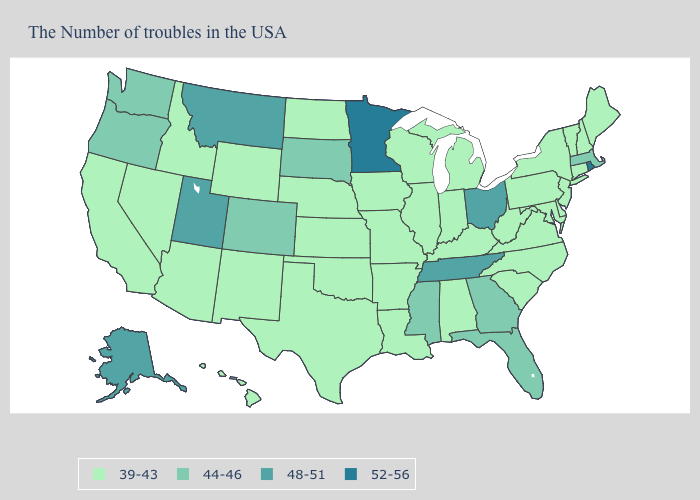Does Idaho have the same value as Oklahoma?
Write a very short answer. Yes. What is the highest value in the South ?
Be succinct. 48-51. What is the value of Kansas?
Give a very brief answer. 39-43. Name the states that have a value in the range 44-46?
Quick response, please. Massachusetts, Florida, Georgia, Mississippi, South Dakota, Colorado, Washington, Oregon. What is the lowest value in states that border Louisiana?
Answer briefly. 39-43. Which states have the lowest value in the USA?
Be succinct. Maine, New Hampshire, Vermont, Connecticut, New York, New Jersey, Delaware, Maryland, Pennsylvania, Virginia, North Carolina, South Carolina, West Virginia, Michigan, Kentucky, Indiana, Alabama, Wisconsin, Illinois, Louisiana, Missouri, Arkansas, Iowa, Kansas, Nebraska, Oklahoma, Texas, North Dakota, Wyoming, New Mexico, Arizona, Idaho, Nevada, California, Hawaii. What is the lowest value in states that border Nevada?
Answer briefly. 39-43. What is the value of Florida?
Concise answer only. 44-46. Does the first symbol in the legend represent the smallest category?
Give a very brief answer. Yes. Does Nebraska have the same value as New York?
Quick response, please. Yes. What is the value of Missouri?
Give a very brief answer. 39-43. Does Oregon have the same value as Maryland?
Answer briefly. No. Among the states that border Wisconsin , does Minnesota have the lowest value?
Write a very short answer. No. Does Ohio have a higher value than Rhode Island?
Answer briefly. No. What is the value of Alaska?
Quick response, please. 48-51. 